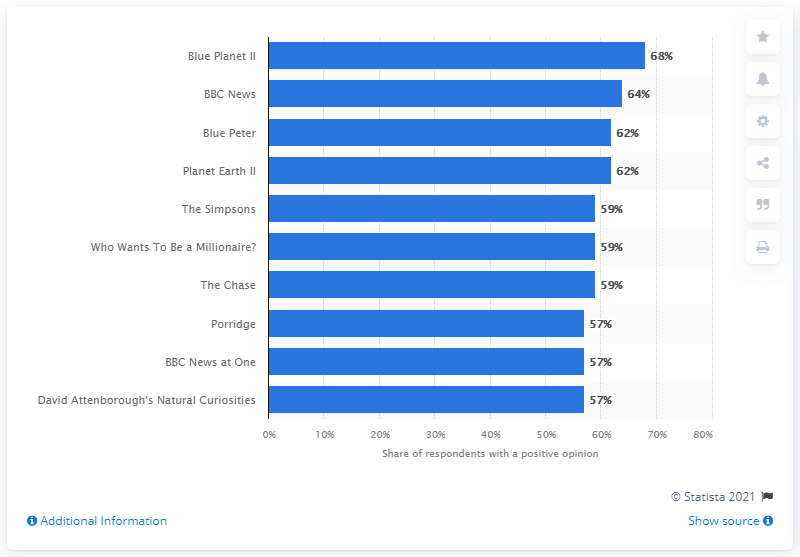Give some essential details in this illustration. In the first quarter of 2021, Blue Planet II was the highest ranked show in the United Kingdom. 